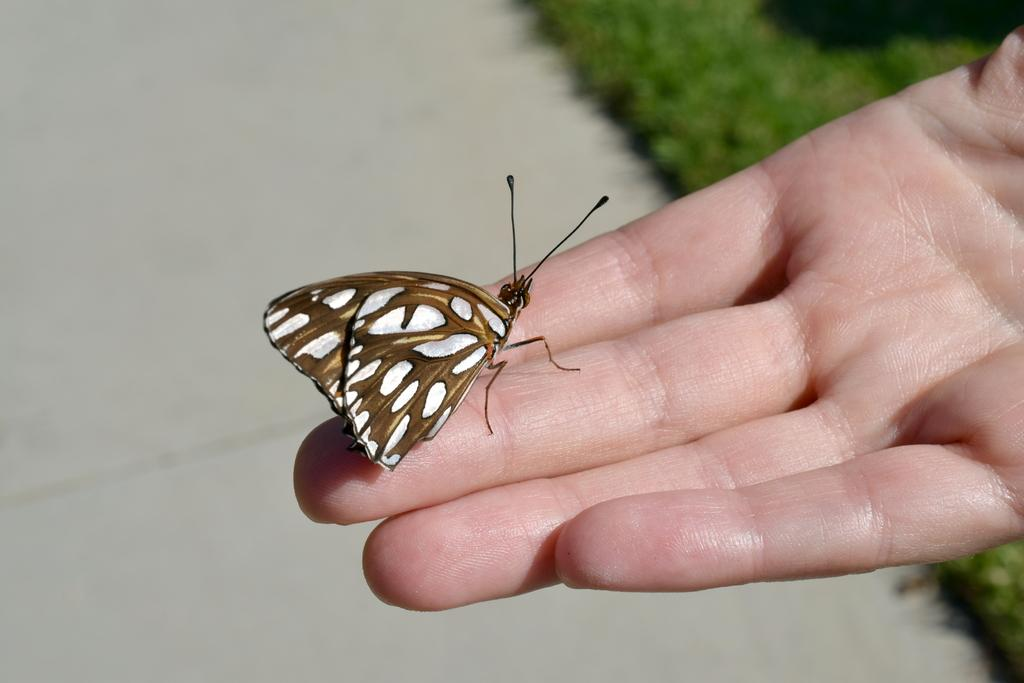Where was the picture taken? The picture was clicked outside. What is the main subject of the image? There is a moth in the center of the image. Is the moth on a person's hand? Yes, the moth is on the hand of a person. What can be seen in the background of the image? There is ground visible in the background of the image, and there is green grass. What type of nut is the person holding in the image? There is no nut present in the image; it features a moth on a person's hand. How does the person feel about the moth in the image? The image does not provide any information about the person's feelings towards the moth. --- Facts: 1. There is a person sitting on a chair in the image. 2. The person is reading a book. 3. The book has a blue cover. 4. There is a table next to the chair. 5. There is a lamp on the table. Absurd Topics: ocean, dance, bird Conversation: What is the person in the image doing? The person is sitting on a chair and reading a book. What color is the book's cover? The book has a blue cover. What is located next to the chair? There is a table next to the chair. What object is on the table? There is a lamp on the table. Reasoning: Let's think step by step in order to produce the conversation. We start by identifying the main subject of the image, which is the person sitting on a chair. Then, we describe the person's activity, which is reading a book. We provide details about the book, such as its color. Finally, we mention the objects located near the chair, including the table and the lamp. Absurd Question/Answer: Can you see the ocean in the image? No, there is no ocean visible in the image. Is the person dancing in the image? No, the person is sitting and reading a book, not dancing. 